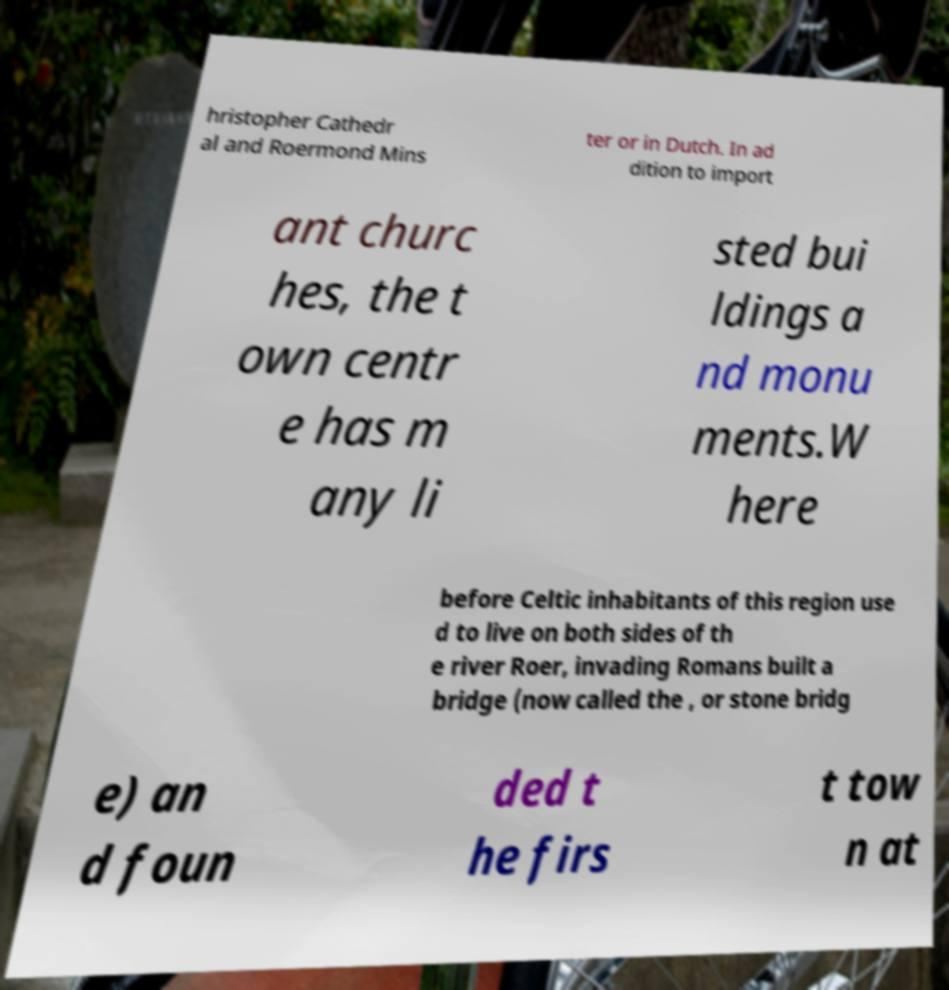I need the written content from this picture converted into text. Can you do that? hristopher Cathedr al and Roermond Mins ter or in Dutch. In ad dition to import ant churc hes, the t own centr e has m any li sted bui ldings a nd monu ments.W here before Celtic inhabitants of this region use d to live on both sides of th e river Roer, invading Romans built a bridge (now called the , or stone bridg e) an d foun ded t he firs t tow n at 